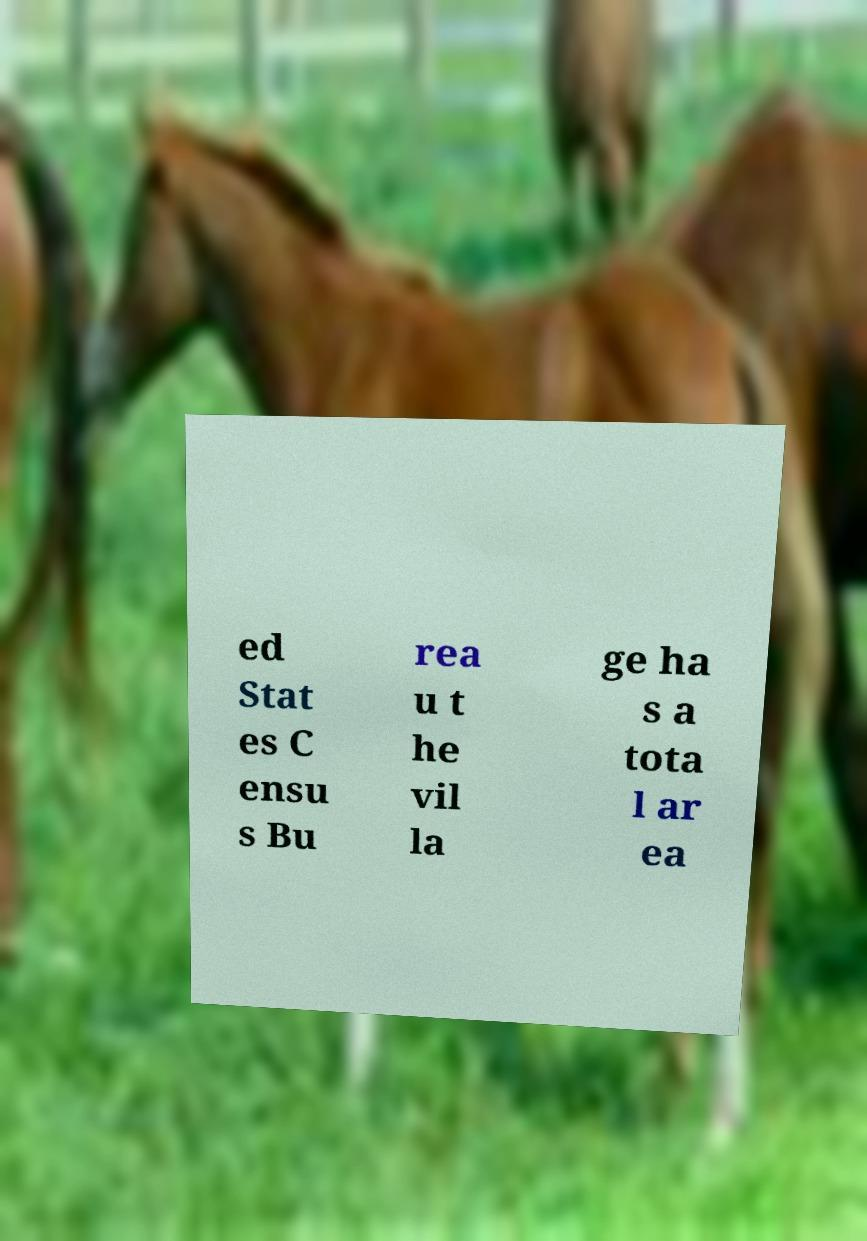Can you accurately transcribe the text from the provided image for me? ed Stat es C ensu s Bu rea u t he vil la ge ha s a tota l ar ea 